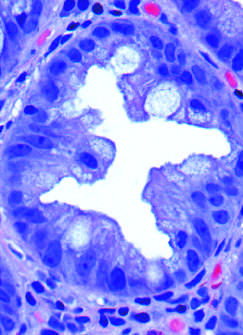what produces a serrated architecture when glands are cut in cross-section?
Answer the question using a single word or phrase. Epithelial crowding 